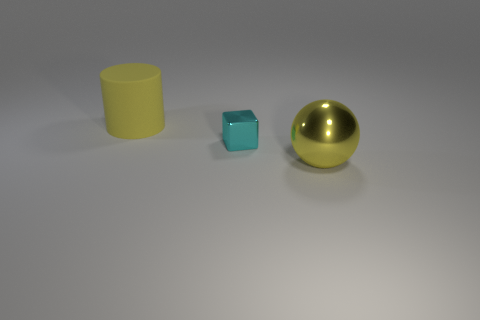Add 2 large green rubber cylinders. How many objects exist? 5 Subtract all balls. How many objects are left? 2 Subtract 1 blocks. How many blocks are left? 0 Add 1 big yellow matte things. How many big yellow matte things are left? 2 Add 1 big red matte balls. How many big red matte balls exist? 1 Subtract 1 yellow spheres. How many objects are left? 2 Subtract all yellow blocks. Subtract all cyan cylinders. How many blocks are left? 1 Subtract all red cylinders. How many gray blocks are left? 0 Subtract all big yellow metallic spheres. Subtract all large yellow matte things. How many objects are left? 1 